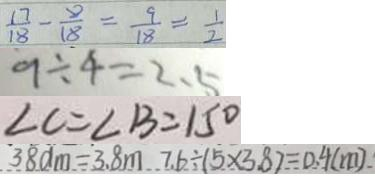Convert formula to latex. <formula><loc_0><loc_0><loc_500><loc_500>\frac { 1 7 } { 1 8 } - \frac { 8 } { 1 8 } = \frac { 9 } { 1 8 } = \frac { 1 } { 2 } 
 9 \div 4 = 2 . 5 
 \angle C = \angle B = 1 5 ^ { \circ } 
 3 8 d m = 3 . 8 m 7 . 6 \div ( 5 \times 3 . 8 ) = 0 . 4 ( m )</formula> 